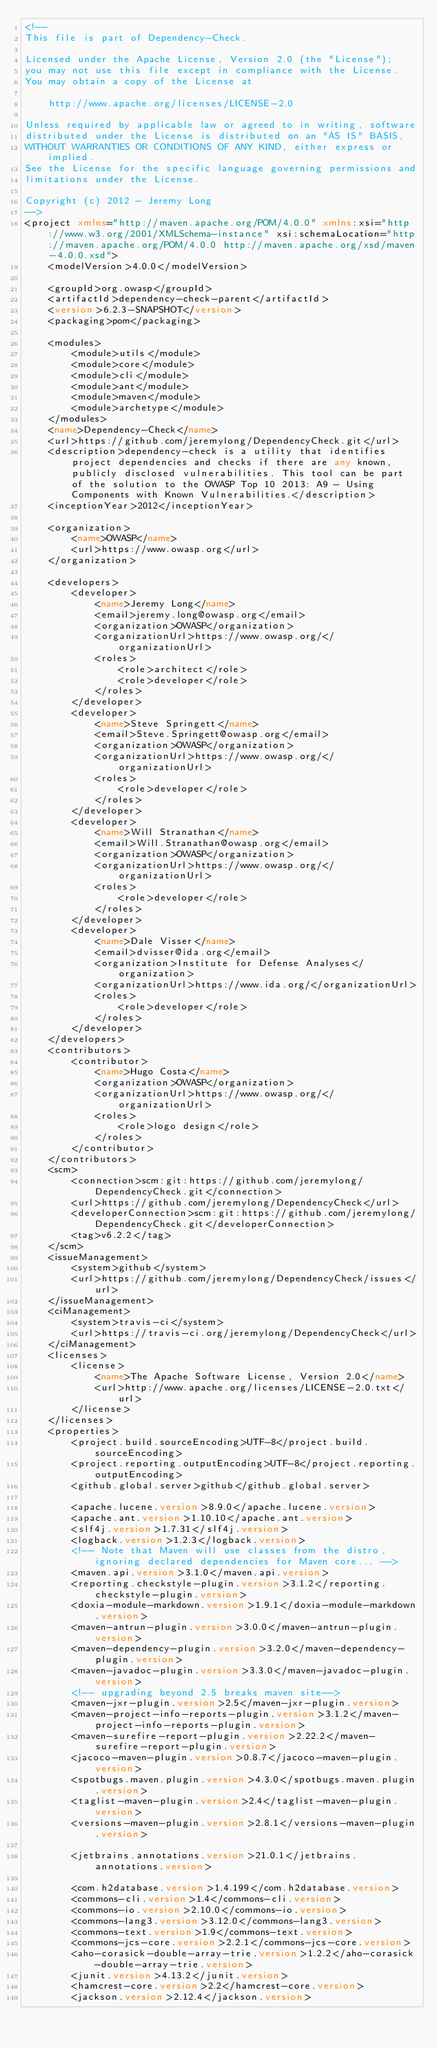<code> <loc_0><loc_0><loc_500><loc_500><_XML_><!--
This file is part of Dependency-Check.

Licensed under the Apache License, Version 2.0 (the "License");
you may not use this file except in compliance with the License.
You may obtain a copy of the License at

    http://www.apache.org/licenses/LICENSE-2.0

Unless required by applicable law or agreed to in writing, software
distributed under the License is distributed on an "AS IS" BASIS,
WITHOUT WARRANTIES OR CONDITIONS OF ANY KIND, either express or implied.
See the License for the specific language governing permissions and
limitations under the License.

Copyright (c) 2012 - Jeremy Long
-->
<project xmlns="http://maven.apache.org/POM/4.0.0" xmlns:xsi="http://www.w3.org/2001/XMLSchema-instance" xsi:schemaLocation="http://maven.apache.org/POM/4.0.0 http://maven.apache.org/xsd/maven-4.0.0.xsd">
    <modelVersion>4.0.0</modelVersion>

    <groupId>org.owasp</groupId>
    <artifactId>dependency-check-parent</artifactId>
    <version>6.2.3-SNAPSHOT</version>
    <packaging>pom</packaging>

    <modules>
        <module>utils</module>
        <module>core</module>
        <module>cli</module>
        <module>ant</module>
        <module>maven</module>
        <module>archetype</module>
    </modules>
    <name>Dependency-Check</name>
    <url>https://github.com/jeremylong/DependencyCheck.git</url>
    <description>dependency-check is a utility that identifies project dependencies and checks if there are any known, publicly disclosed vulnerabilities. This tool can be part of the solution to the OWASP Top 10 2013: A9 - Using Components with Known Vulnerabilities.</description>
    <inceptionYear>2012</inceptionYear>

    <organization>
        <name>OWASP</name>
        <url>https://www.owasp.org</url>
    </organization>

    <developers>
        <developer>
            <name>Jeremy Long</name>
            <email>jeremy.long@owasp.org</email>
            <organization>OWASP</organization>
            <organizationUrl>https://www.owasp.org/</organizationUrl>
            <roles>
                <role>architect</role>
                <role>developer</role>
            </roles>
        </developer>
        <developer>
            <name>Steve Springett</name>
            <email>Steve.Springett@owasp.org</email>
            <organization>OWASP</organization>
            <organizationUrl>https://www.owasp.org/</organizationUrl>
            <roles>
                <role>developer</role>
            </roles>
        </developer>
        <developer>
            <name>Will Stranathan</name>
            <email>Will.Stranathan@owasp.org</email>
            <organization>OWASP</organization>
            <organizationUrl>https://www.owasp.org/</organizationUrl>
            <roles>
                <role>developer</role>
            </roles>
        </developer>
        <developer>
            <name>Dale Visser</name>
            <email>dvisser@ida.org</email>
            <organization>Institute for Defense Analyses</organization>
            <organizationUrl>https://www.ida.org/</organizationUrl>
            <roles>
                <role>developer</role>
            </roles>
        </developer>
    </developers>
    <contributors>
        <contributor>
            <name>Hugo Costa</name>
            <organization>OWASP</organization>
            <organizationUrl>https://www.owasp.org/</organizationUrl>
            <roles>
                <role>logo design</role>
            </roles>
        </contributor>
    </contributors>
    <scm>
        <connection>scm:git:https://github.com/jeremylong/DependencyCheck.git</connection>
        <url>https://github.com/jeremylong/DependencyCheck</url>
        <developerConnection>scm:git:https://github.com/jeremylong/DependencyCheck.git</developerConnection>
        <tag>v6.2.2</tag>
    </scm>
    <issueManagement>
        <system>github</system>
        <url>https://github.com/jeremylong/DependencyCheck/issues</url>
    </issueManagement>
    <ciManagement>
        <system>travis-ci</system>
        <url>https://travis-ci.org/jeremylong/DependencyCheck</url>
    </ciManagement>
    <licenses>
        <license>
            <name>The Apache Software License, Version 2.0</name>
            <url>http://www.apache.org/licenses/LICENSE-2.0.txt</url>
        </license>
    </licenses>
    <properties>
        <project.build.sourceEncoding>UTF-8</project.build.sourceEncoding>
        <project.reporting.outputEncoding>UTF-8</project.reporting.outputEncoding>
        <github.global.server>github</github.global.server>
        
        <apache.lucene.version>8.9.0</apache.lucene.version>
        <apache.ant.version>1.10.10</apache.ant.version>
        <slf4j.version>1.7.31</slf4j.version>
        <logback.version>1.2.3</logback.version>
        <!-- Note that Maven will use classes from the distro, ignoring declared dependencies for Maven core... -->
        <maven.api.version>3.1.0</maven.api.version>
        <reporting.checkstyle-plugin.version>3.1.2</reporting.checkstyle-plugin.version>
        <doxia-module-markdown.version>1.9.1</doxia-module-markdown.version>
        <maven-antrun-plugin.version>3.0.0</maven-antrun-plugin.version>
        <maven-dependency-plugin.version>3.2.0</maven-dependency-plugin.version>
        <maven-javadoc-plugin.version>3.3.0</maven-javadoc-plugin.version>
        <!-- upgrading beyond 2.5 breaks maven site-->
        <maven-jxr-plugin.version>2.5</maven-jxr-plugin.version>
        <maven-project-info-reports-plugin.version>3.1.2</maven-project-info-reports-plugin.version>
        <maven-surefire-report-plugin.version>2.22.2</maven-surefire-report-plugin.version>
        <jacoco-maven-plugin.version>0.8.7</jacoco-maven-plugin.version>
        <spotbugs.maven.plugin.version>4.3.0</spotbugs.maven.plugin.version>
        <taglist-maven-plugin.version>2.4</taglist-maven-plugin.version>
        <versions-maven-plugin.version>2.8.1</versions-maven-plugin.version>

        <jetbrains.annotations.version>21.0.1</jetbrains.annotations.version>

        <com.h2database.version>1.4.199</com.h2database.version>
        <commons-cli.version>1.4</commons-cli.version>
        <commons-io.version>2.10.0</commons-io.version>
        <commons-lang3.version>3.12.0</commons-lang3.version>
        <commons-text.version>1.9</commons-text.version>
        <commons-jcs-core.version>2.2.1</commons-jcs-core.version>
        <aho-corasick-double-array-trie.version>1.2.2</aho-corasick-double-array-trie.version>
        <junit.version>4.13.2</junit.version>
        <hamcrest-core.version>2.2</hamcrest-core.version>
        <jackson.version>2.12.4</jackson.version></code> 